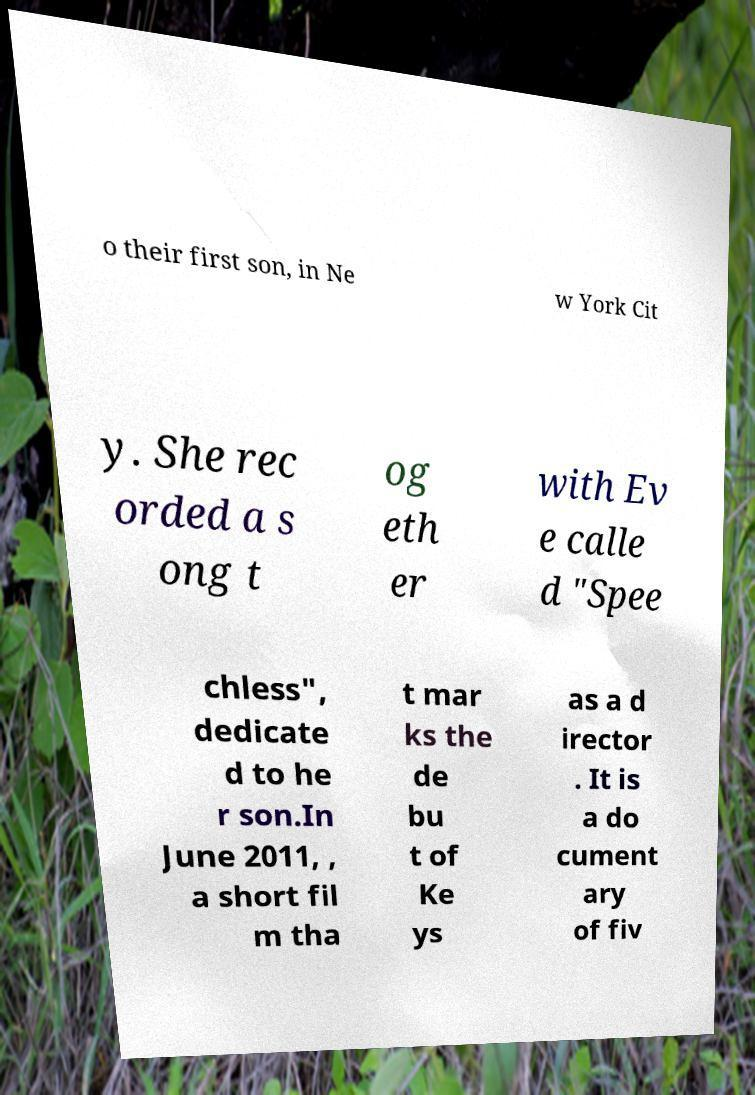Can you accurately transcribe the text from the provided image for me? o their first son, in Ne w York Cit y. She rec orded a s ong t og eth er with Ev e calle d "Spee chless", dedicate d to he r son.In June 2011, , a short fil m tha t mar ks the de bu t of Ke ys as a d irector . It is a do cument ary of fiv 